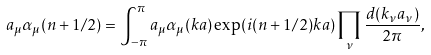<formula> <loc_0><loc_0><loc_500><loc_500>a _ { \mu } \alpha _ { \mu } ( n + 1 / 2 ) = \int _ { - \pi } ^ { \pi } a _ { \mu } \alpha _ { \mu } ( k a ) \exp ( i ( n + 1 / 2 ) k a ) \prod _ { \nu } \frac { d ( k _ { \nu } a _ { \nu } ) } { 2 \pi } ,</formula> 